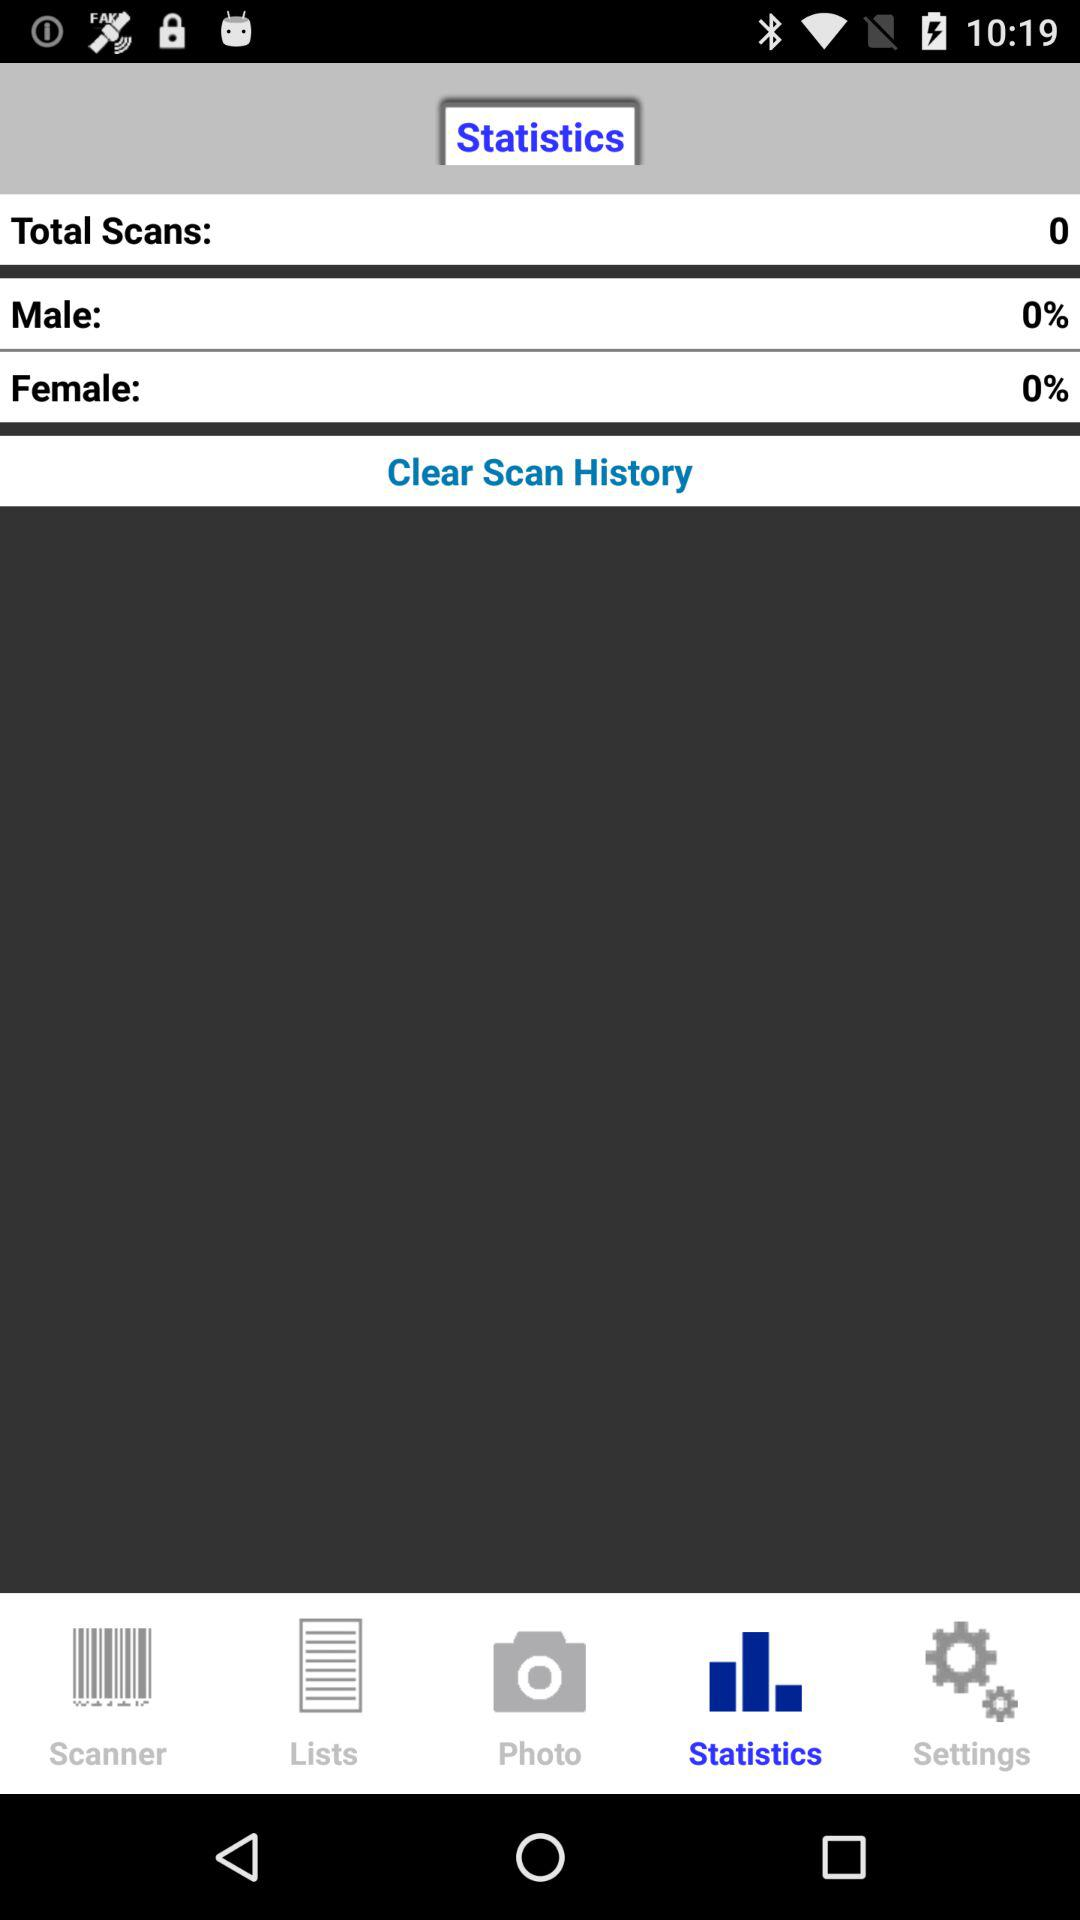What is the name of the application?
When the provided information is insufficient, respond with <no answer>. <no answer> 